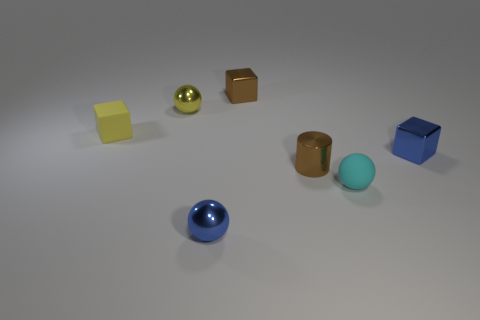Subtract all shiny cubes. How many cubes are left? 1 Add 2 green shiny objects. How many objects exist? 9 Subtract all balls. How many objects are left? 4 Subtract 0 green cylinders. How many objects are left? 7 Subtract all small rubber objects. Subtract all large gray metal objects. How many objects are left? 5 Add 1 tiny brown shiny cylinders. How many tiny brown shiny cylinders are left? 2 Add 7 big brown rubber things. How many big brown rubber things exist? 7 